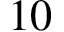Convert formula to latex. <formula><loc_0><loc_0><loc_500><loc_500>1 0</formula> 